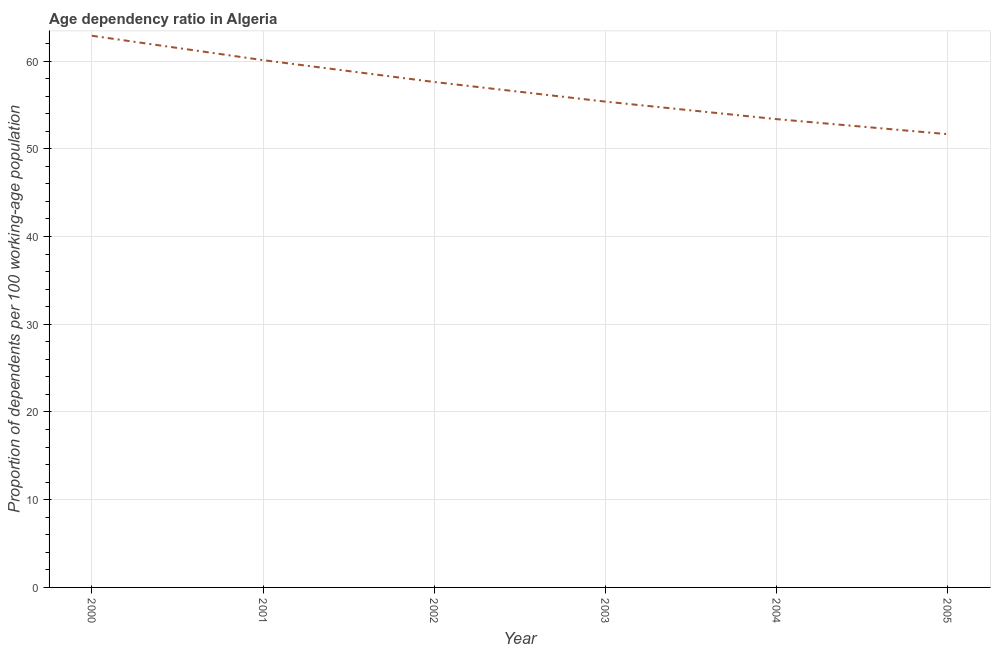What is the age dependency ratio in 2004?
Keep it short and to the point. 53.38. Across all years, what is the maximum age dependency ratio?
Provide a succinct answer. 62.89. Across all years, what is the minimum age dependency ratio?
Make the answer very short. 51.67. In which year was the age dependency ratio maximum?
Your answer should be compact. 2000. In which year was the age dependency ratio minimum?
Your answer should be compact. 2005. What is the sum of the age dependency ratio?
Your answer should be compact. 341.03. What is the difference between the age dependency ratio in 2001 and 2002?
Keep it short and to the point. 2.49. What is the average age dependency ratio per year?
Ensure brevity in your answer.  56.84. What is the median age dependency ratio?
Give a very brief answer. 56.5. What is the ratio of the age dependency ratio in 2000 to that in 2003?
Make the answer very short. 1.14. What is the difference between the highest and the second highest age dependency ratio?
Make the answer very short. 2.78. What is the difference between the highest and the lowest age dependency ratio?
Give a very brief answer. 11.22. In how many years, is the age dependency ratio greater than the average age dependency ratio taken over all years?
Your answer should be compact. 3. How many lines are there?
Your answer should be compact. 1. What is the difference between two consecutive major ticks on the Y-axis?
Your response must be concise. 10. Are the values on the major ticks of Y-axis written in scientific E-notation?
Keep it short and to the point. No. Does the graph contain any zero values?
Offer a very short reply. No. Does the graph contain grids?
Make the answer very short. Yes. What is the title of the graph?
Make the answer very short. Age dependency ratio in Algeria. What is the label or title of the Y-axis?
Your response must be concise. Proportion of dependents per 100 working-age population. What is the Proportion of dependents per 100 working-age population of 2000?
Provide a short and direct response. 62.89. What is the Proportion of dependents per 100 working-age population of 2001?
Your answer should be very brief. 60.11. What is the Proportion of dependents per 100 working-age population in 2002?
Provide a succinct answer. 57.61. What is the Proportion of dependents per 100 working-age population in 2003?
Your answer should be very brief. 55.38. What is the Proportion of dependents per 100 working-age population of 2004?
Your answer should be very brief. 53.38. What is the Proportion of dependents per 100 working-age population of 2005?
Provide a short and direct response. 51.67. What is the difference between the Proportion of dependents per 100 working-age population in 2000 and 2001?
Your answer should be compact. 2.78. What is the difference between the Proportion of dependents per 100 working-age population in 2000 and 2002?
Offer a terse response. 5.27. What is the difference between the Proportion of dependents per 100 working-age population in 2000 and 2003?
Provide a succinct answer. 7.51. What is the difference between the Proportion of dependents per 100 working-age population in 2000 and 2004?
Make the answer very short. 9.5. What is the difference between the Proportion of dependents per 100 working-age population in 2000 and 2005?
Make the answer very short. 11.22. What is the difference between the Proportion of dependents per 100 working-age population in 2001 and 2002?
Give a very brief answer. 2.49. What is the difference between the Proportion of dependents per 100 working-age population in 2001 and 2003?
Provide a short and direct response. 4.73. What is the difference between the Proportion of dependents per 100 working-age population in 2001 and 2004?
Offer a terse response. 6.72. What is the difference between the Proportion of dependents per 100 working-age population in 2001 and 2005?
Your answer should be very brief. 8.44. What is the difference between the Proportion of dependents per 100 working-age population in 2002 and 2003?
Your answer should be very brief. 2.24. What is the difference between the Proportion of dependents per 100 working-age population in 2002 and 2004?
Your response must be concise. 4.23. What is the difference between the Proportion of dependents per 100 working-age population in 2002 and 2005?
Ensure brevity in your answer.  5.95. What is the difference between the Proportion of dependents per 100 working-age population in 2003 and 2004?
Make the answer very short. 2. What is the difference between the Proportion of dependents per 100 working-age population in 2003 and 2005?
Your response must be concise. 3.71. What is the difference between the Proportion of dependents per 100 working-age population in 2004 and 2005?
Provide a succinct answer. 1.72. What is the ratio of the Proportion of dependents per 100 working-age population in 2000 to that in 2001?
Your answer should be compact. 1.05. What is the ratio of the Proportion of dependents per 100 working-age population in 2000 to that in 2002?
Offer a terse response. 1.09. What is the ratio of the Proportion of dependents per 100 working-age population in 2000 to that in 2003?
Your response must be concise. 1.14. What is the ratio of the Proportion of dependents per 100 working-age population in 2000 to that in 2004?
Ensure brevity in your answer.  1.18. What is the ratio of the Proportion of dependents per 100 working-age population in 2000 to that in 2005?
Ensure brevity in your answer.  1.22. What is the ratio of the Proportion of dependents per 100 working-age population in 2001 to that in 2002?
Your answer should be very brief. 1.04. What is the ratio of the Proportion of dependents per 100 working-age population in 2001 to that in 2003?
Ensure brevity in your answer.  1.08. What is the ratio of the Proportion of dependents per 100 working-age population in 2001 to that in 2004?
Ensure brevity in your answer.  1.13. What is the ratio of the Proportion of dependents per 100 working-age population in 2001 to that in 2005?
Make the answer very short. 1.16. What is the ratio of the Proportion of dependents per 100 working-age population in 2002 to that in 2003?
Offer a terse response. 1.04. What is the ratio of the Proportion of dependents per 100 working-age population in 2002 to that in 2004?
Provide a short and direct response. 1.08. What is the ratio of the Proportion of dependents per 100 working-age population in 2002 to that in 2005?
Provide a succinct answer. 1.11. What is the ratio of the Proportion of dependents per 100 working-age population in 2003 to that in 2005?
Give a very brief answer. 1.07. What is the ratio of the Proportion of dependents per 100 working-age population in 2004 to that in 2005?
Offer a very short reply. 1.03. 